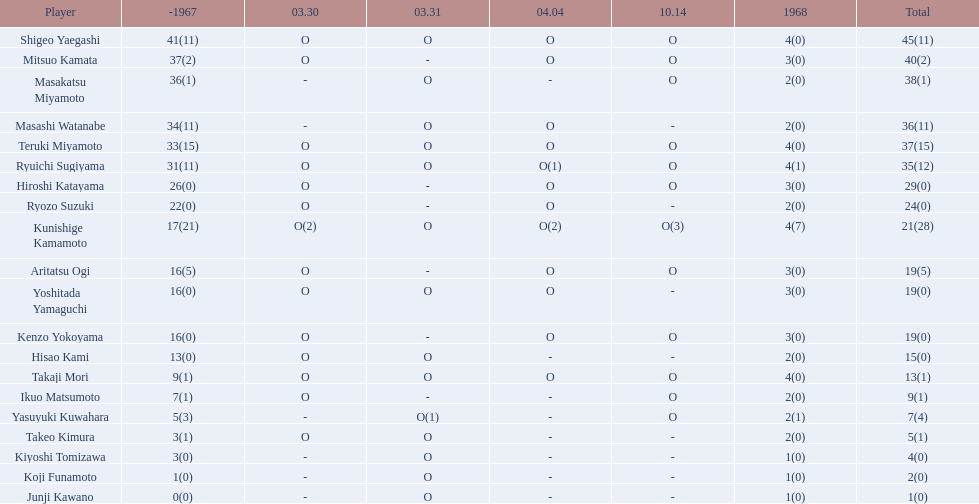Who took part in the 1968 japanese football? Shigeo Yaegashi, Mitsuo Kamata, Masakatsu Miyamoto, Masashi Watanabe, Teruki Miyamoto, Ryuichi Sugiyama, Hiroshi Katayama, Ryozo Suzuki, Kunishige Kamamoto, Aritatsu Ogi, Yoshitada Yamaguchi, Kenzo Yokoyama, Hisao Kami, Takaji Mori, Ikuo Matsumoto, Yasuyuki Kuwahara, Takeo Kimura, Kiyoshi Tomizawa, Koji Funamoto, Junji Kawano. How many points did takaji mori earn in total? 13(1). What was junju kawano's total point count? 1(0). Who scored more points? Takaji Mori. 